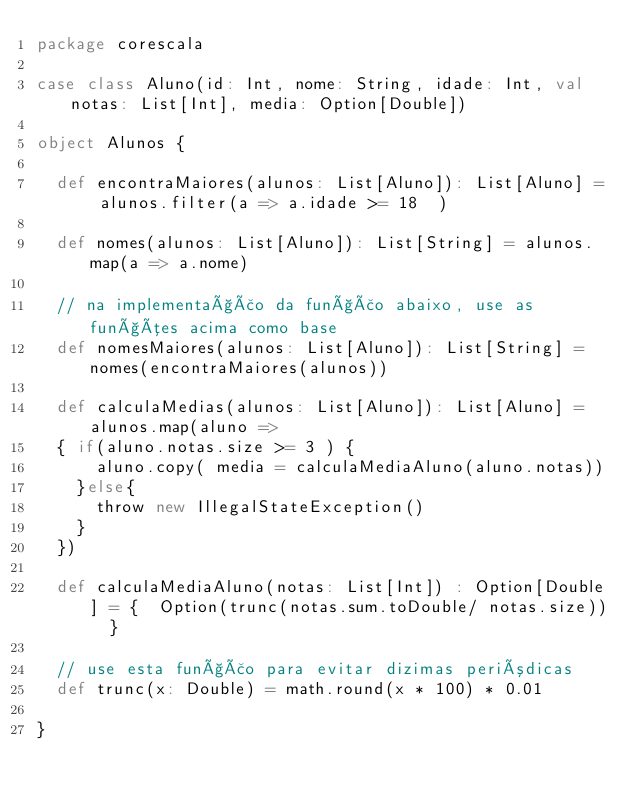Convert code to text. <code><loc_0><loc_0><loc_500><loc_500><_Scala_>package corescala

case class Aluno(id: Int, nome: String, idade: Int, val notas: List[Int], media: Option[Double])

object Alunos {
  
  def encontraMaiores(alunos: List[Aluno]): List[Aluno] = alunos.filter(a => a.idade >= 18  )

  def nomes(alunos: List[Aluno]): List[String] = alunos.map(a => a.nome)

  // na implementação da função abaixo, use as funções acima como base
  def nomesMaiores(alunos: List[Aluno]): List[String] = nomes(encontraMaiores(alunos))

  def calculaMedias(alunos: List[Aluno]): List[Aluno] = alunos.map(aluno => 
  { if(aluno.notas.size >= 3 ) {
      aluno.copy( media = calculaMediaAluno(aluno.notas))
    }else{
      throw new IllegalStateException() 
    }
  })
 
  def calculaMediaAluno(notas: List[Int]) : Option[Double] = {  Option(trunc(notas.sum.toDouble/ notas.size))  }
  
  // use esta função para evitar dizimas periódicas
  def trunc(x: Double) = math.round(x * 100) * 0.01
  
}
</code> 